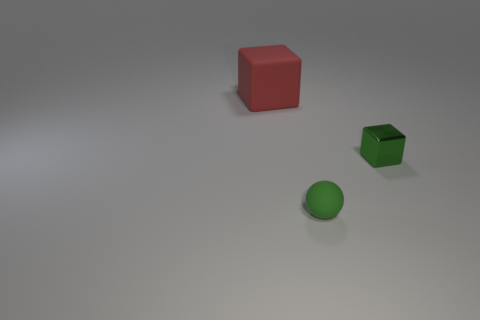There is a rubber thing that is right of the cube on the left side of the green metal cube; what shape is it? The object you're referring to is a sphere. More specifically, it's a green rubber sphere situated to the right of the red cube and to the left side of the smaller green metal cube. 